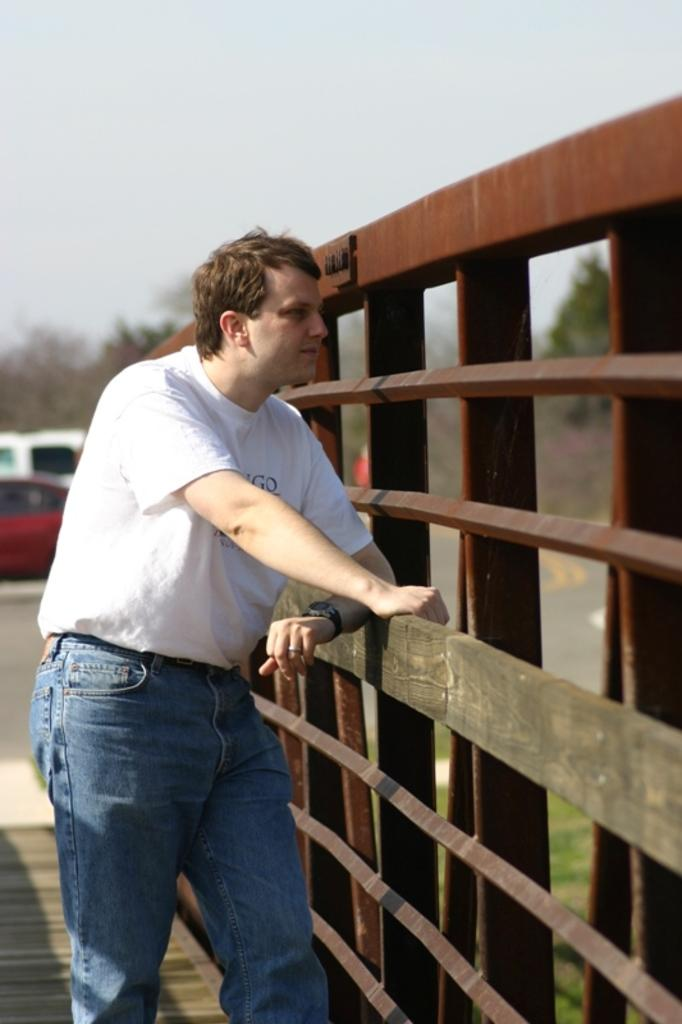What is the main subject of the image? There is a person in the image. What is located beside the person? There is a fencing beside the person. What can be seen behind the person? There is a group of trees behind the person. What else is visible in the background? Vehicles and grass are present in the background. What is visible at the top of the image? The sky is visible at the top of the image. What type of muscle is being exercised by the person in the image? There is no indication of the person exercising or using any muscles in the image. 